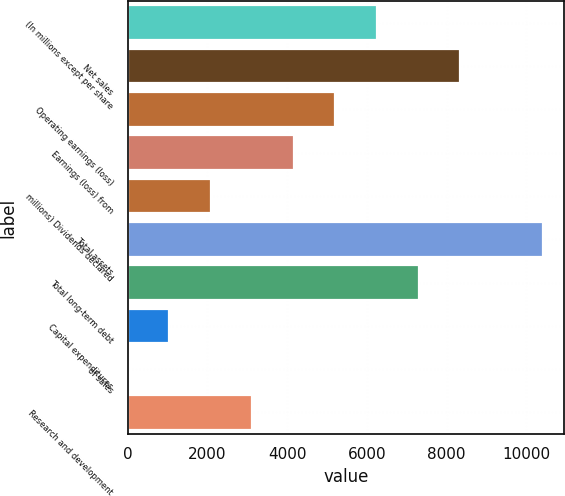Convert chart. <chart><loc_0><loc_0><loc_500><loc_500><bar_chart><fcel>(In millions except per share<fcel>Net sales<fcel>Operating earnings (loss)<fcel>Earnings (loss) from<fcel>millions) Dividends declared<fcel>Total assets<fcel>Total long-term debt<fcel>Capital expenditures<fcel>of sales<fcel>Research and development<nl><fcel>6255.04<fcel>8339.02<fcel>5213.05<fcel>4171.06<fcel>2087.08<fcel>10423<fcel>7297.03<fcel>1045.09<fcel>3.1<fcel>3129.07<nl></chart> 